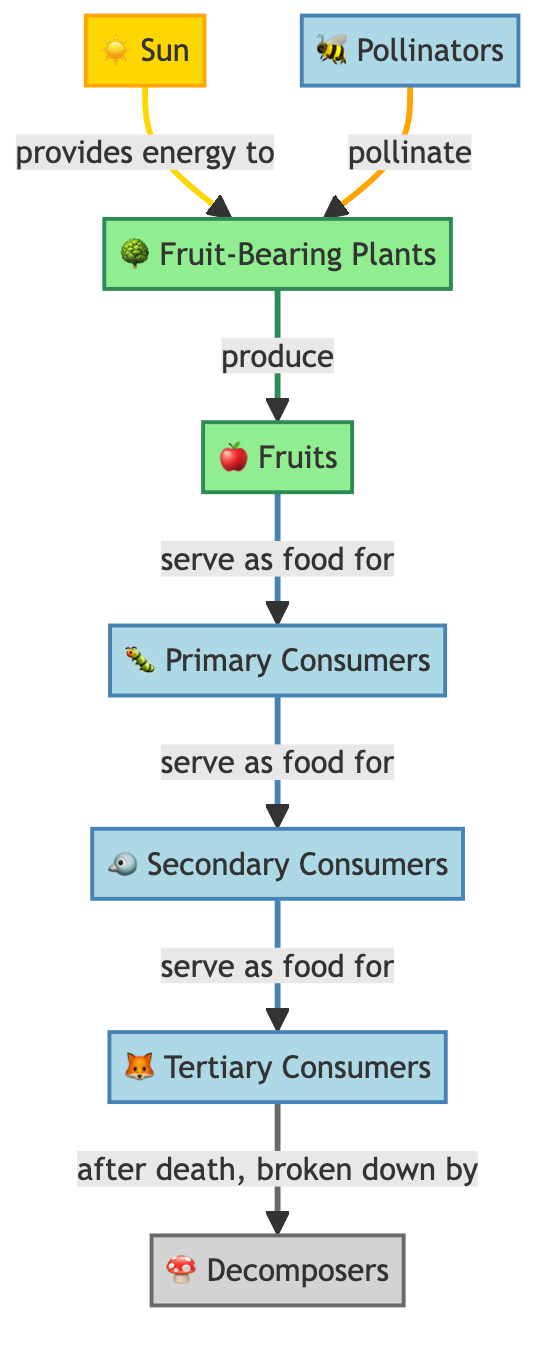What is the primary source of energy in this food chain? The diagram indicates that the primary source of energy is the Sun, which is illustrated as providing energy to the fruit-bearing plants.
Answer: Sun How many types of consumers are represented in the diagram? The diagram shows three types of consumers: primary consumers, secondary consumers, and tertiary consumers, which can be counted from the nodes.
Answer: 3 What do pollinators do for fruit-bearing plants? According to the diagram, pollinators pollinate the fruit-bearing plants, which is a crucial step in their production process.
Answer: Pollinate What serves as food for secondary consumers? The diagram indicates that primary consumers serve as food for secondary consumers, establishing a direct link in the food chain.
Answer: Primary Consumers Which node decomposes the dead tertiary consumers? The diagram specifies that decomposers, represented by the decomposer node, are responsible for breaking down the dead tertiary consumers.
Answer: Decomposers What do fruit-bearing plants produce? The diagram illustrates that fruit-bearing plants produce fruits, which is a critical output of their role in the food chain.
Answer: Fruits Which animal is a tertiary consumer in this food chain? Based on the diagram, the tertiary consumer is represented by the specific node labeled "Tertiary Consumers," indicating that it occupies the highest tier in this part of the food chain.
Answer: Tertiary Consumers How do fruits fit into this food chain? The diagram illustrates that fruits produce from fruit-bearing plants and serve as food for primary consumers, reflecting their role in nutrient transfer.
Answer: Food for Primary Consumers What is the relationship between the sun and fruit-bearing plants? The diagram indicates a direct connection where the sun provides energy to fruit-bearing plants, essential for their growth and development.
Answer: Provides Energy 